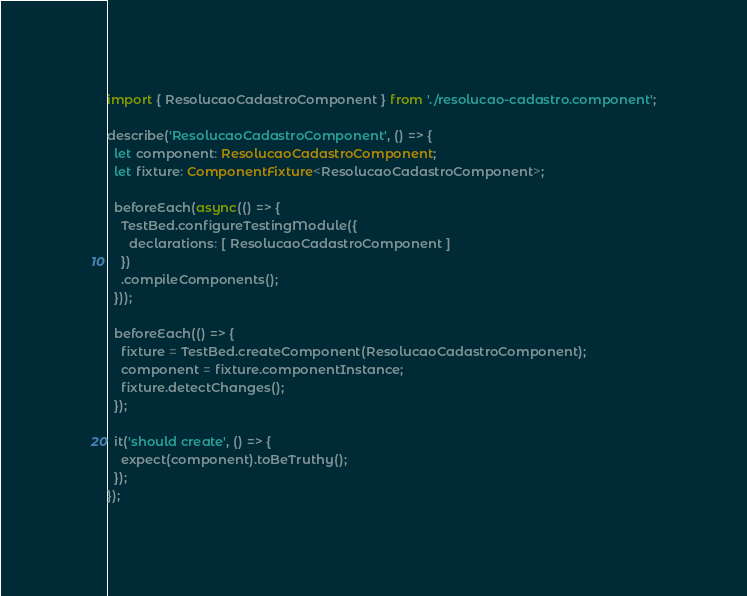<code> <loc_0><loc_0><loc_500><loc_500><_TypeScript_>import { ResolucaoCadastroComponent } from './resolucao-cadastro.component';

describe('ResolucaoCadastroComponent', () => {
  let component: ResolucaoCadastroComponent;
  let fixture: ComponentFixture<ResolucaoCadastroComponent>;

  beforeEach(async(() => {
    TestBed.configureTestingModule({
      declarations: [ ResolucaoCadastroComponent ]
    })
    .compileComponents();
  }));

  beforeEach(() => {
    fixture = TestBed.createComponent(ResolucaoCadastroComponent);
    component = fixture.componentInstance;
    fixture.detectChanges();
  });

  it('should create', () => {
    expect(component).toBeTruthy();
  });
});
</code> 